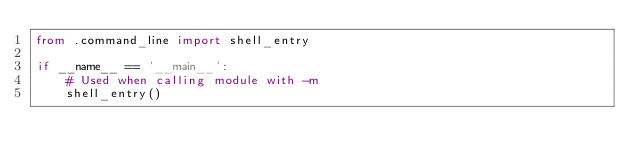Convert code to text. <code><loc_0><loc_0><loc_500><loc_500><_Python_>from .command_line import shell_entry

if __name__ == '__main__':
    # Used when calling module with -m
    shell_entry()
</code> 